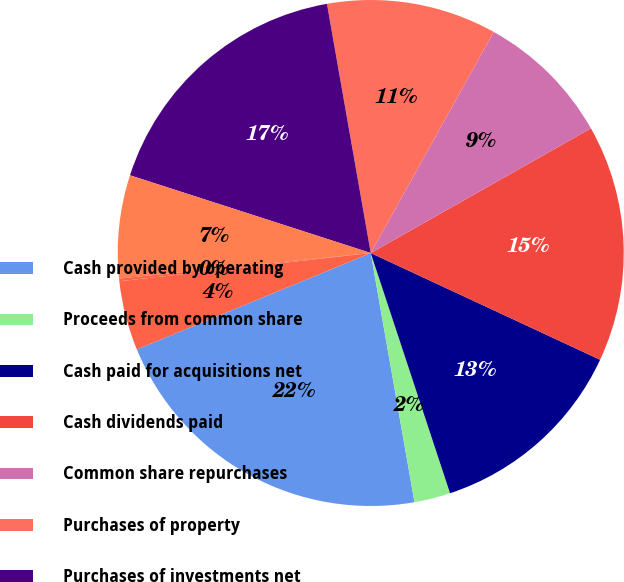<chart> <loc_0><loc_0><loc_500><loc_500><pie_chart><fcel>Cash provided by operating<fcel>Proceeds from common share<fcel>Cash paid for acquisitions net<fcel>Cash dividends paid<fcel>Common share repurchases<fcel>Purchases of property<fcel>Purchases of investments net<fcel>Other<fcel>Effect of exchange rate<fcel>Net (decrease) increase in<nl><fcel>21.54%<fcel>2.31%<fcel>12.99%<fcel>15.13%<fcel>8.72%<fcel>10.85%<fcel>17.26%<fcel>6.58%<fcel>0.17%<fcel>4.44%<nl></chart> 